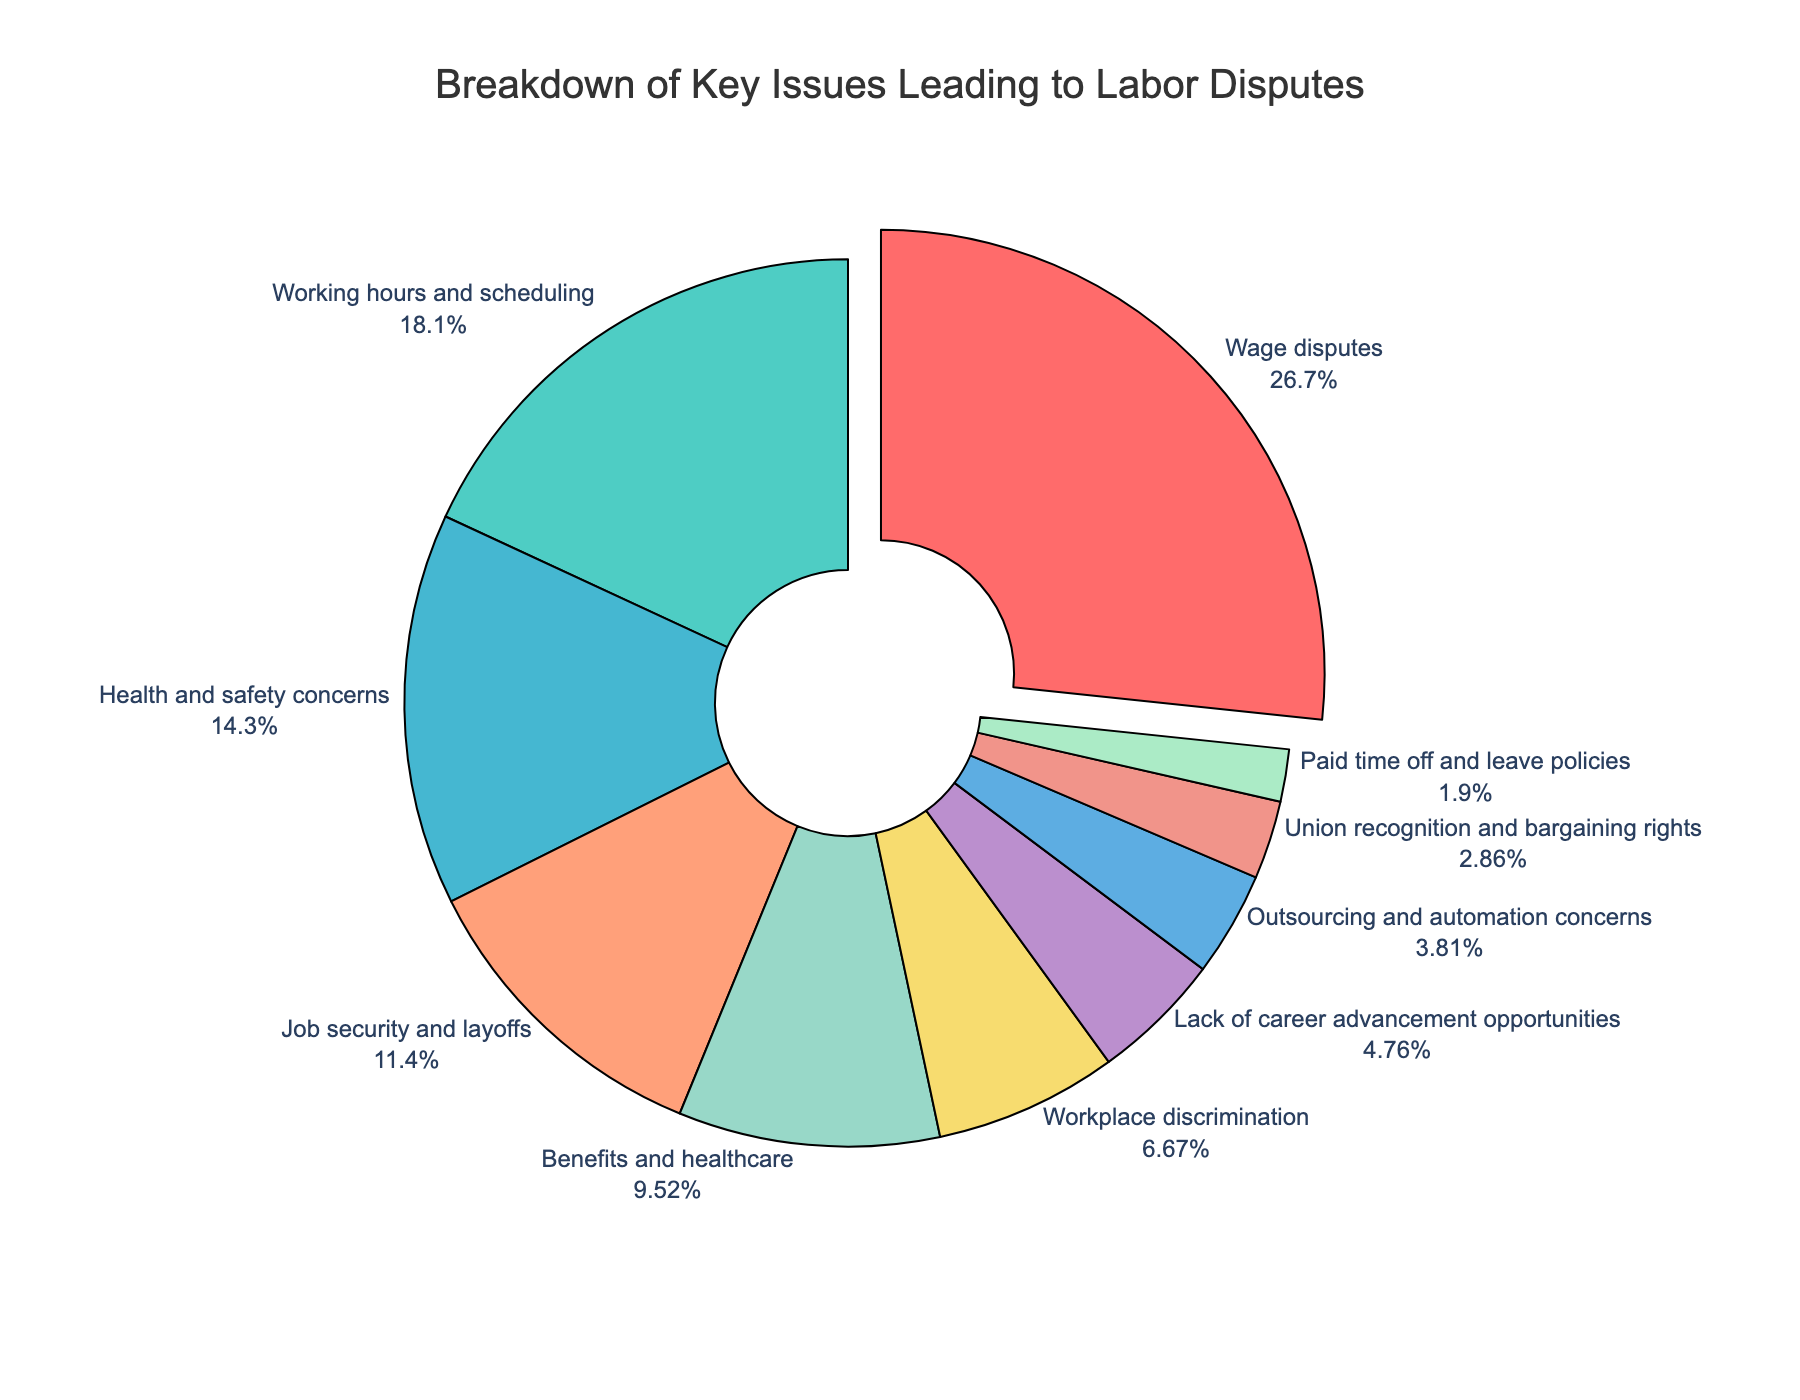What percentage of labor disputes are due to wage disputes? Identify the section labeled "Wage disputes" in the pie chart and read the percentage value associated with it.
Answer: 28% Which issue has a higher percentage: Health and safety concerns or Job security and layoffs? Compare the percentages of "Health and safety concerns" (15%) and "Job security and layoffs" (12%) by looking at the pie chart.
Answer: Health and safety concerns How much more frequent are disputes about wage issues compared to those about working hours and scheduling? Subtract the percentage of "Working hours and scheduling" (19%) from "Wage disputes" (28%) to see the difference. 28% - 19% = 9%
Answer: 9% What's the combined percentage of disputes related to health and safety concerns, workplace discrimination, and benefits and healthcare? Sum the percentages for "Health and safety concerns" (15%), "Workplace discrimination" (7%), and "Benefits and healthcare" (10%). 15% + 7% + 10% = 32%
Answer: 32% Is the percentage of disputes about outsourcing and automation concerns greater than or less than the disputes about lack of career advancement opportunities? Compare the percentage values of "Outsourcing and automation concerns" (4%) and "Lack of career advancement opportunities" (5%).
Answer: Less Which issue related to labor disputes has the smallest percentage, and what is it? Identify the segment of the pie chart with the smallest percentage, labeled "Paid time off and leave policies".
Answer: Paid time off and leave policies What is the total percentage of all issues that lead to labor disputes? Verify that the sum of all the percentages in a pie chart equals 100%.
Answer: 100% How many issues have a percentage greater than or equal to 10%? Count the segments in the pie chart with a percentage of 10% or higher: Wage disputes (28%), Working hours and scheduling (19%), Health and safety concerns (15%), and Benefits and healthcare (10%). There are 4 such issues.
Answer: 4 If the percentage of disputes about union recognition and bargaining rights doubled, what would it be? Double the percentage value of "Union recognition and bargaining rights" (3%). 3% * 2 = 6%
Answer: 6% Would the sum of percentages for job security and layoffs, and paid time off and leave policies be more or less than health and safety concerns? Sum the percentages of "Job security and layoffs" (12%) and "Paid time off and leave policies" (2%), then compare the sum (12% + 2% = 14%) to "Health and safety concerns" (15%). 14% < 15%
Answer: Less 